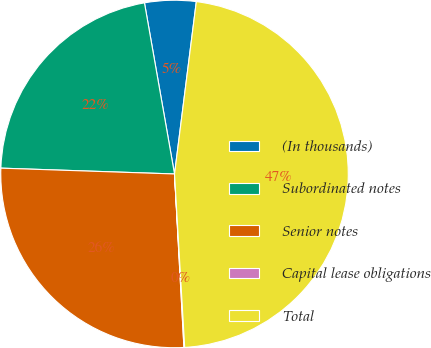<chart> <loc_0><loc_0><loc_500><loc_500><pie_chart><fcel>(In thousands)<fcel>Subordinated notes<fcel>Senior notes<fcel>Capital lease obligations<fcel>Total<nl><fcel>4.77%<fcel>21.7%<fcel>26.4%<fcel>0.07%<fcel>47.07%<nl></chart> 